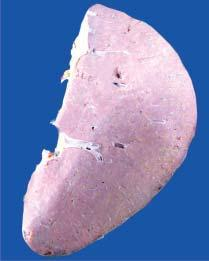what shows presence of plae waxy translucency in a map-like pattern?
Answer the question using a single word or phrase. The sectioned surface 